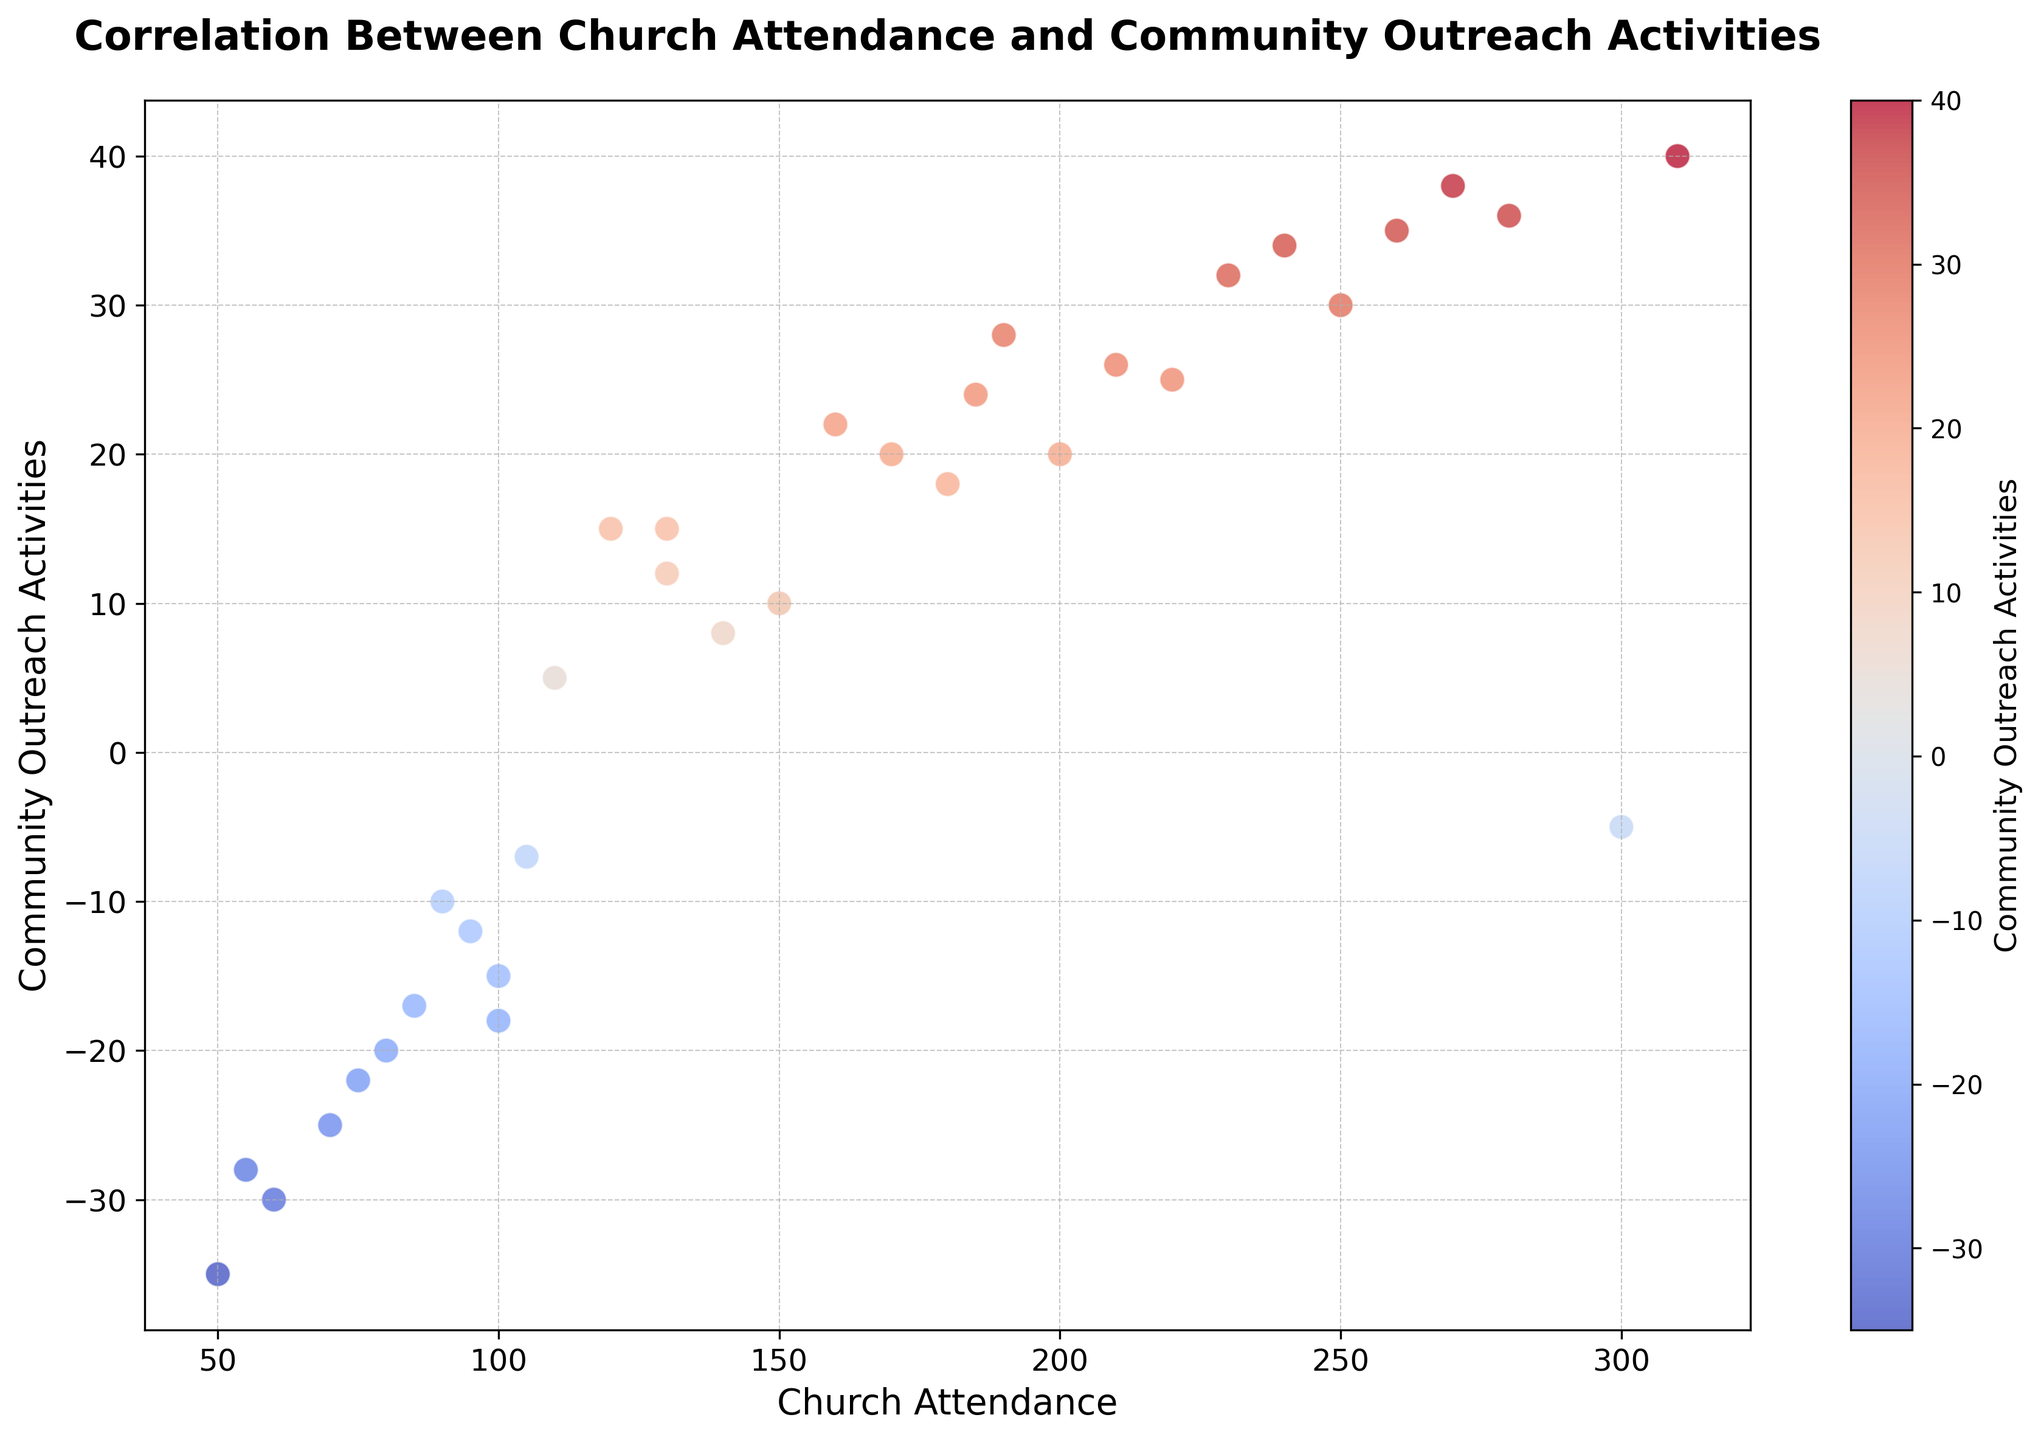What is the general trend observed between Church Attendance and Community Outreach Activities? Looking at the scatter plot, we see that counties with higher church attendance tend to have more community outreach activities, while those with lower attendance have fewer activities. This suggests a positive correlation between church attendance and community outreach activities overall.
Answer: Positive correlation Which county has the highest church attendance, and how many community outreach activities does it have? By identifying the point with the highest x-coordinate (Church Attendance), we see that Chester has the highest church attendance at 310. The corresponding y-coordinate shows it has 40 community outreach activities.
Answer: Chester, 40 Identify the counties with negative community outreach activities and list their church attendance values. By examining points below the x-axis (negative y-coordinates), the counties with negative community outreach activities include Allegheny (300), Bedford (80), Blair (90), Cambria (100), Cameron (70), Clearfield (95), Clinton (60), Elk (50), Forest (85), Fulton (75), Greene (105), Huntingdon (55), Jefferson (100).
Answer: Allegheny (300), Bedford (80), Blair (90), Cambria (100), Cameron (70), Clearfield (95), Clinton (60), Elk (50), Forest (85), Fulton (75), Greene (105), Huntingdon (55), Jefferson (100) Which counties have community outreach activities close to 20, and what are their church attendance values? Points close to a y-coordinate of 20 are identified. The counties fitting this criterion are Armstrong (150), Beaver (220), Butler (200), Fayette (170).
Answer: Armstrong (150), Beaver (220), Butler (200), Fayette (170) What is the church attendance value for the county with the highest negative community outreach activities? The county with the highest magnitude of negative community outreach activities is Elk with -35. The corresponding x-coordinate shows a church attendance value of 50.
Answer: 50 Does any county lie close to the intersection of Church Attendance and Community Outreach Activities axes? Intersection corresponds to (0,0). No county data point is precisely at this intersection, but counties like Allegheny (300, -5) and Bradford (110, 5) are close to crossing the axes in terms of community outreach activities being near zero.
Answer: No county exactly, Allegheny and Bradford near axes Find the average community outreach activities for counties with church attendance over 200. Counties with church attendance over 200 are Allegheny (300, -5), Berks (250, 30), Bucks (260, 35), Chester (310, 40), Cumberland (230, 32), Dauphin (210, 26), Delaware (270, 38), Erie (240, 34), Lackawanna (280, 36). Sum the y-values: (-5 + 30 + 35 + 40 + 32 + 26 + 38 + 34 + 36) = 266. Average = 266/9 = 29.56.
Answer: 29.56 Which county has the largest positive community outreach activities, and what is its church attendance? By finding the highest y-coordinate, Chester has 40 community outreach activities. Corresponding church attendance is 310.
Answer: Chester, 310 